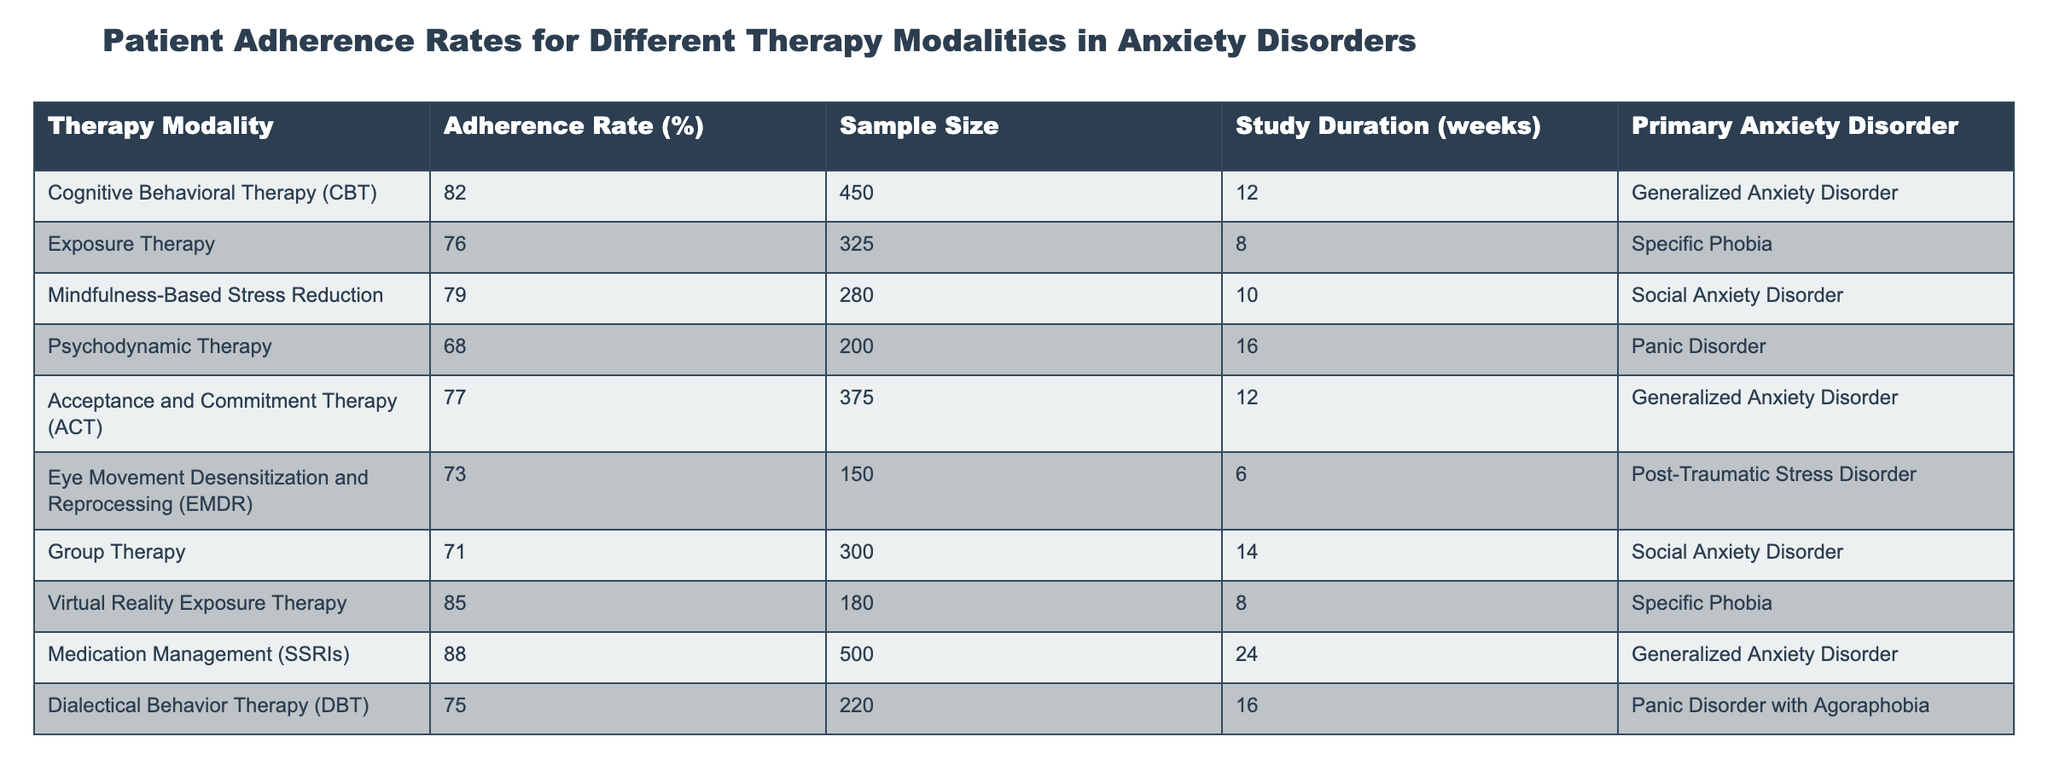What is the adherence rate for Cognitive Behavioral Therapy (CBT)? The table shows the adherence rate for CBT listed under the "Adherence Rate (%)" column, where it is specified as 82%.
Answer: 82% Which therapy modality has the highest adherence rate? By examining the "Adherence Rate (%)" column in the table, it is clear that Medication Management (SSRIs) has the highest rate at 88%.
Answer: 88% What is the sample size for Exposure Therapy? The table provides the sample size for Exposure Therapy in the "Sample Size" column, revealing it to be 325 participants.
Answer: 325 What is the average adherence rate for therapies targeting Generalized Anxiety Disorder? From the table, the adherence rates for the therapies targeting Generalized Anxiety Disorder are 82% (CBT), 77% (ACT), and 88% (Medication Management). To find the average, sum these rates (82 + 77 + 88 = 247) and divide by 3, resulting in an average of approximately 82.33%.
Answer: 82.33% Is the adherence rate for Psychodynamic Therapy higher than 70%? The table lists the adherence rate for Psychodynamic Therapy as 68%. Therefore, it is not higher than 70%, making the statement false.
Answer: No Which therapy modality has a sample size greater than 300 and what is its adherence rate? Looking through the "Sample Size" column, Group Therapy has a sample size of 300, and its adherence rate listed in the "Adherence Rate (%)" column is 71%.
Answer: 71% What is the difference in adherence rates between Virtual Reality Exposure Therapy and Eye Movement Desensitization and Reprocessing (EMDR)? According to the "Adherence Rate (%)" column, Virtual Reality Exposure Therapy has an adherence rate of 85% and EMDR has a rate of 73%. The difference is calculated by subtracting the two rates (85 - 73 = 12).
Answer: 12 How many different primary anxiety disorders are represented in the table? The table includes six unique primary anxiety disorders: Generalized Anxiety Disorder, Specific Phobia, Social Anxiety Disorder, Panic Disorder, Post-Traumatic Stress Disorder, and Panic Disorder with Agoraphobia. This totals to six distinct disorders.
Answer: 6 Is there a therapy modality with an adherence rate of 76% or lower? The table indicates that several therapy modalities have adherence rates of 76% or lower, including Psychodynamic Therapy (68%) and Group Therapy (71%). Thus, the statement is true.
Answer: Yes 